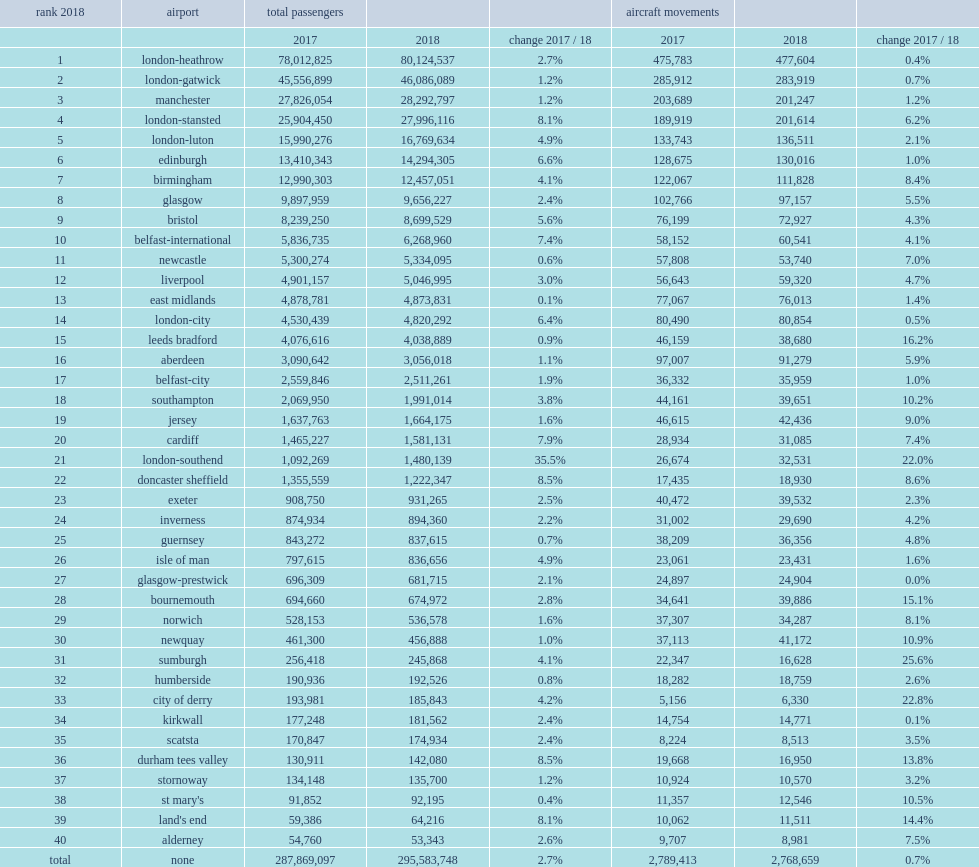What was the rank of edinburgh airport in 2018? 6.0. 